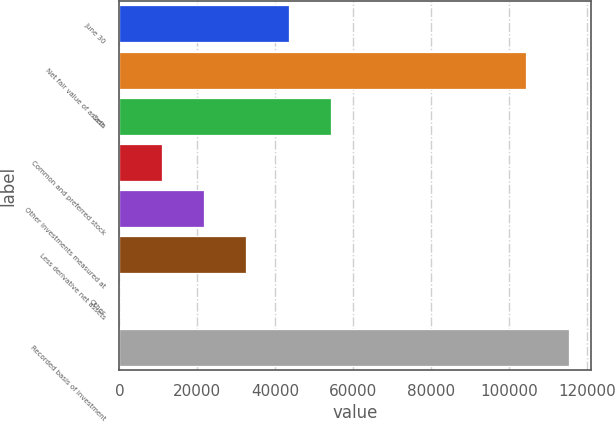Convert chart. <chart><loc_0><loc_0><loc_500><loc_500><bar_chart><fcel>June 30<fcel>Net fair value of assets<fcel>Cash<fcel>Common and preferred stock<fcel>Other investments measured at<fcel>Less derivative net assets<fcel>Other<fcel>Recorded basis of investment<nl><fcel>43424<fcel>104369<fcel>54279<fcel>10859<fcel>21714<fcel>32569<fcel>4<fcel>115224<nl></chart> 